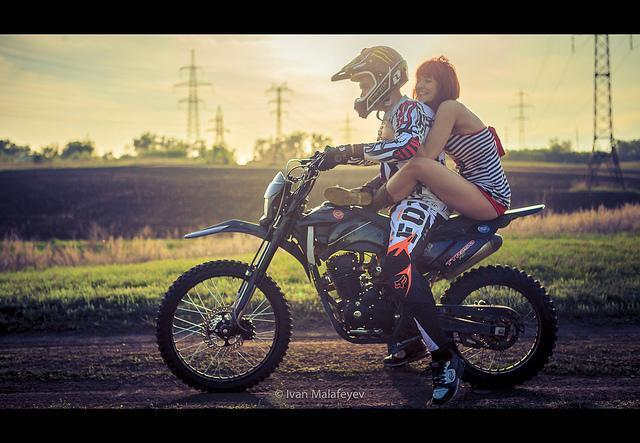Who is wearing the most safety gear?
Indicate the correct response by choosing from the four available options to answer the question.
Options: Bike, no one, man, woman. Man. 